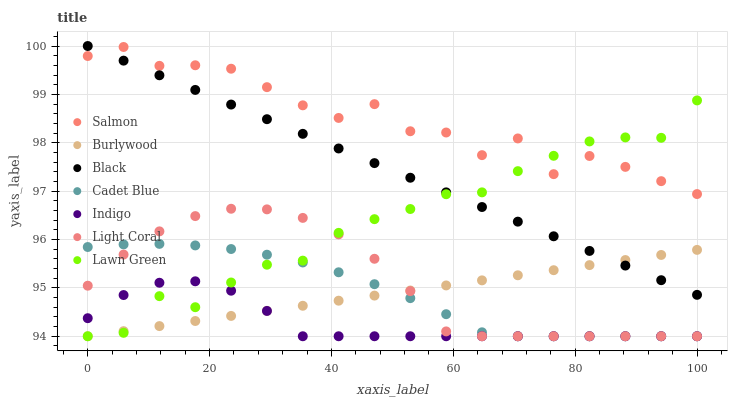Does Indigo have the minimum area under the curve?
Answer yes or no. Yes. Does Salmon have the maximum area under the curve?
Answer yes or no. Yes. Does Cadet Blue have the minimum area under the curve?
Answer yes or no. No. Does Cadet Blue have the maximum area under the curve?
Answer yes or no. No. Is Black the smoothest?
Answer yes or no. Yes. Is Salmon the roughest?
Answer yes or no. Yes. Is Cadet Blue the smoothest?
Answer yes or no. No. Is Cadet Blue the roughest?
Answer yes or no. No. Does Lawn Green have the lowest value?
Answer yes or no. Yes. Does Salmon have the lowest value?
Answer yes or no. No. Does Black have the highest value?
Answer yes or no. Yes. Does Cadet Blue have the highest value?
Answer yes or no. No. Is Burlywood less than Salmon?
Answer yes or no. Yes. Is Salmon greater than Indigo?
Answer yes or no. Yes. Does Lawn Green intersect Black?
Answer yes or no. Yes. Is Lawn Green less than Black?
Answer yes or no. No. Is Lawn Green greater than Black?
Answer yes or no. No. Does Burlywood intersect Salmon?
Answer yes or no. No. 